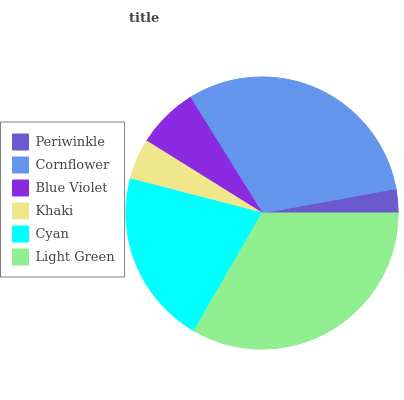Is Periwinkle the minimum?
Answer yes or no. Yes. Is Light Green the maximum?
Answer yes or no. Yes. Is Cornflower the minimum?
Answer yes or no. No. Is Cornflower the maximum?
Answer yes or no. No. Is Cornflower greater than Periwinkle?
Answer yes or no. Yes. Is Periwinkle less than Cornflower?
Answer yes or no. Yes. Is Periwinkle greater than Cornflower?
Answer yes or no. No. Is Cornflower less than Periwinkle?
Answer yes or no. No. Is Cyan the high median?
Answer yes or no. Yes. Is Blue Violet the low median?
Answer yes or no. Yes. Is Light Green the high median?
Answer yes or no. No. Is Light Green the low median?
Answer yes or no. No. 